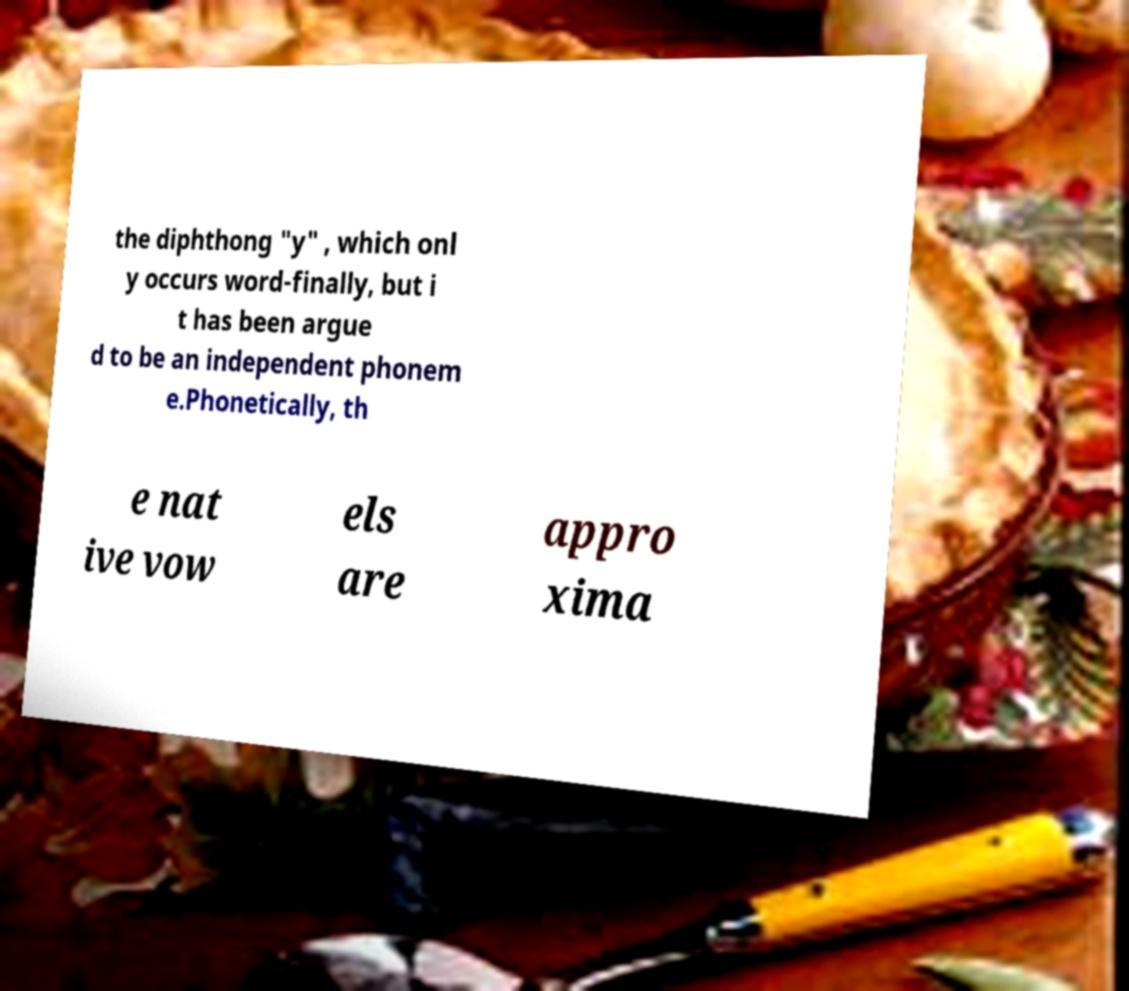What messages or text are displayed in this image? I need them in a readable, typed format. the diphthong "y" , which onl y occurs word-finally, but i t has been argue d to be an independent phonem e.Phonetically, th e nat ive vow els are appro xima 